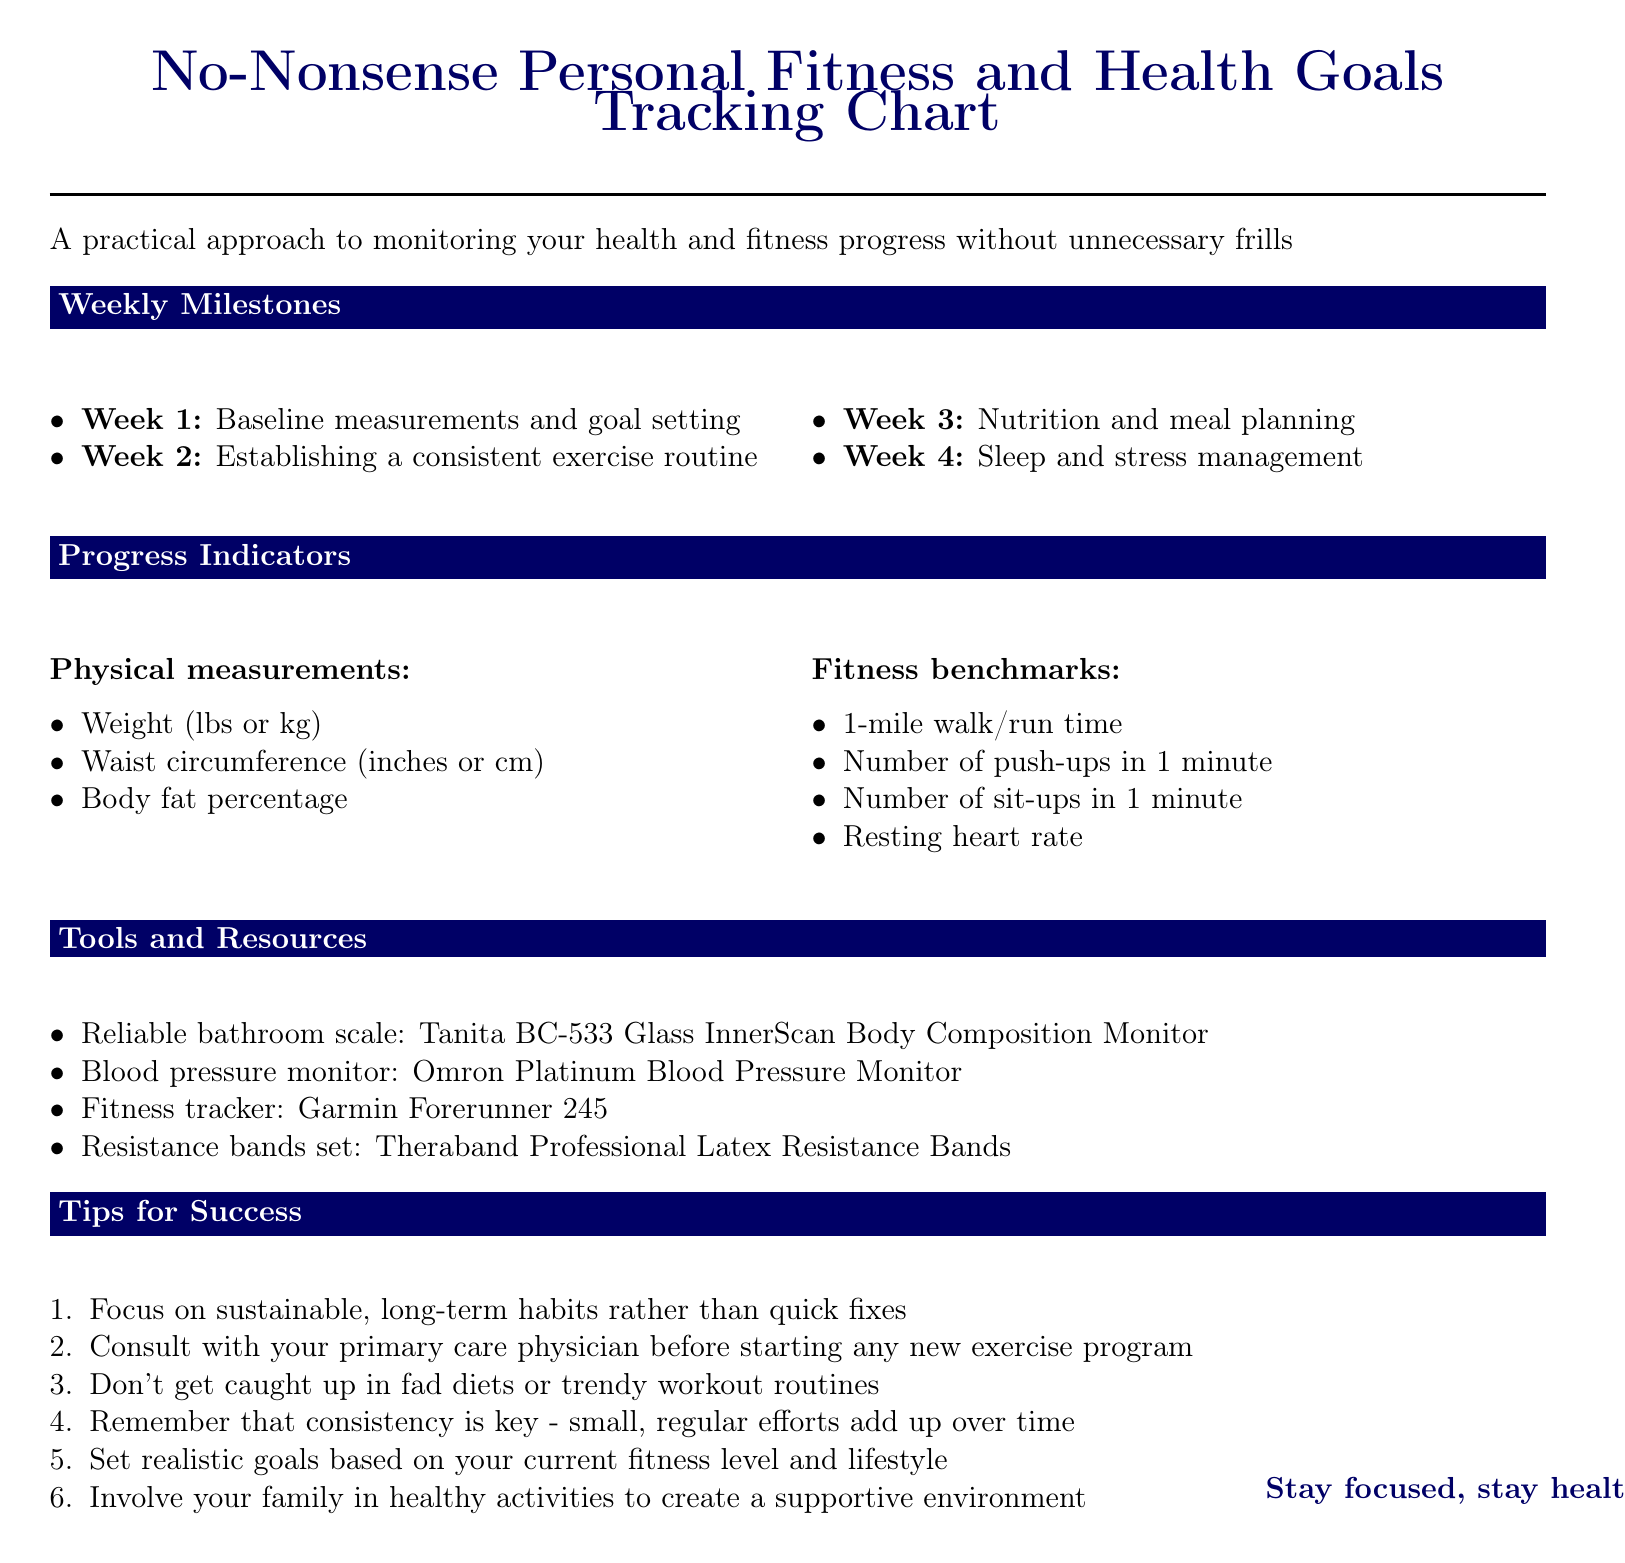What is the title of the document? The title of the document is explicitly stated at the top and describes its main focus.
Answer: No-Nonsense Personal Fitness and Health Goals Tracking Chart How many weeks are outlined in the tracking chart? The document lists a total of four weeks, each with specific milestones and activities.
Answer: 4 What activity is suggested for Week 3? The activity for Week 3 focuses on nutrition and meal planning.
Answer: Track daily calorie intake using a reputable app like MyFitnessPal What is the purpose of the Tanita BC-533 scale? The document specifies the purpose of this tool related to health monitoring.
Answer: Accurate weight and body fat percentage measurements Which category has the metric "Resting heart rate"? The document organizes metrics into categories, providing a logical structure for fitness measurements.
Answer: Fitness benchmarks What is one tip provided for success? The document includes a list of tips, highlighting important practices for achieving fitness goals.
Answer: Focus on sustainable, long-term habits rather than quick fixes How often should you practice deep breathing exercises according to Week 4? The document outlines activities per week, including frequency recommendations for stress management.
Answer: Daily What is the focus of Week 2? Each week has a specific focus, guiding the reader on what areas to concentrate on for their fitness journey.
Answer: Establishing a consistent exercise routine 